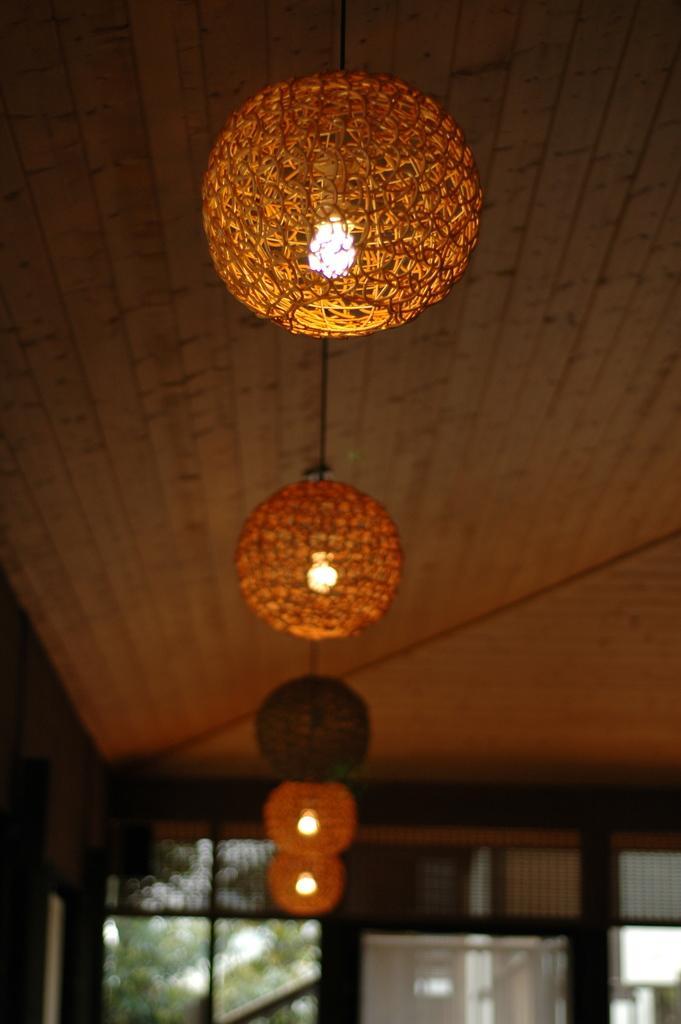Describe this image in one or two sentences. Here we can see lights and roof. Background it is blurry and we can see glass. 